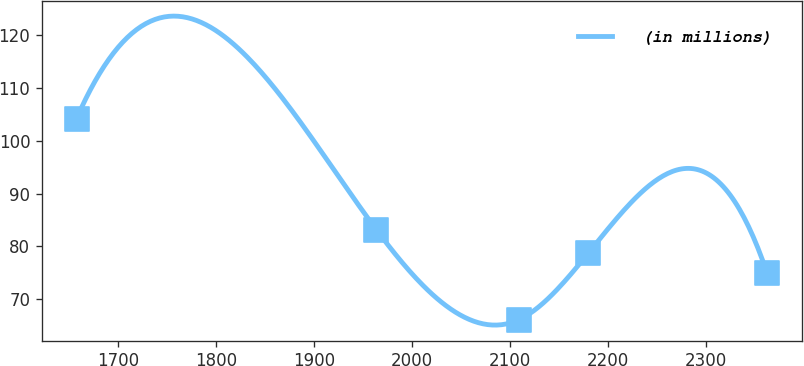Convert chart to OTSL. <chart><loc_0><loc_0><loc_500><loc_500><line_chart><ecel><fcel>(in millions)<nl><fcel>1657.8<fcel>104.22<nl><fcel>1963.91<fcel>83.14<nl><fcel>2109.72<fcel>66.13<nl><fcel>2180.2<fcel>78.74<nl><fcel>2362.6<fcel>74.93<nl></chart> 